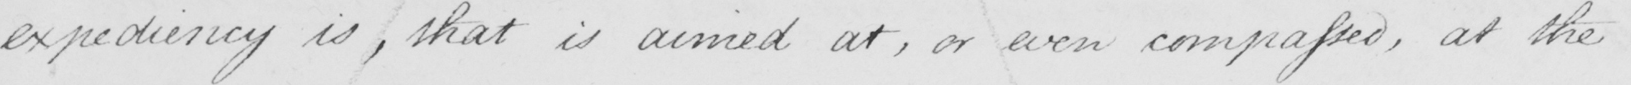What is written in this line of handwriting? expediency is , that is aimed at , or even compassed , at the 